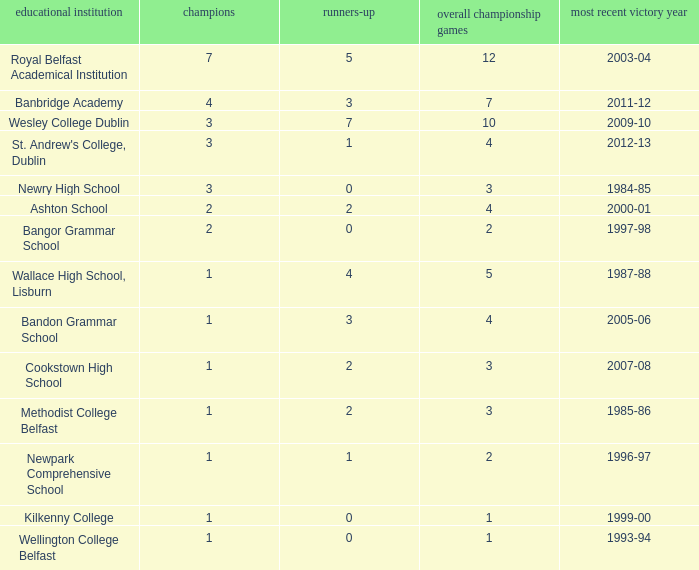What the name of  the school where the last win in 2007-08? Cookstown High School. 